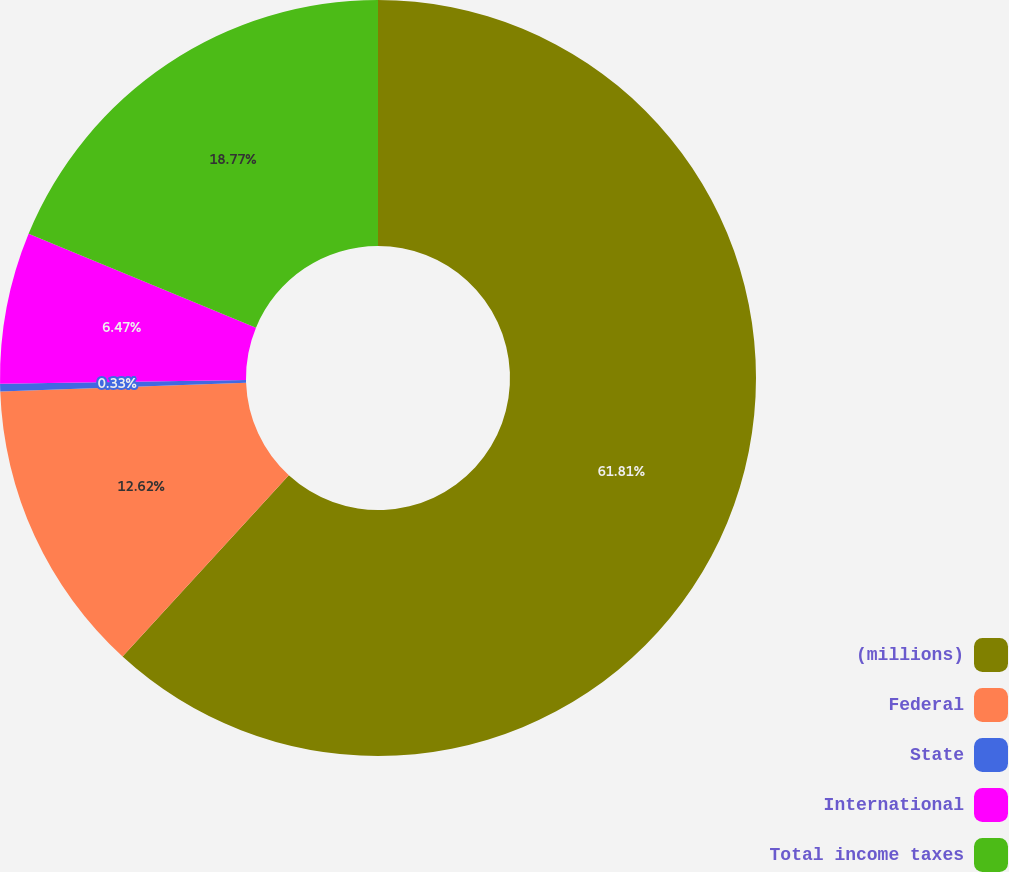<chart> <loc_0><loc_0><loc_500><loc_500><pie_chart><fcel>(millions)<fcel>Federal<fcel>State<fcel>International<fcel>Total income taxes<nl><fcel>61.81%<fcel>12.62%<fcel>0.33%<fcel>6.47%<fcel>18.77%<nl></chart> 